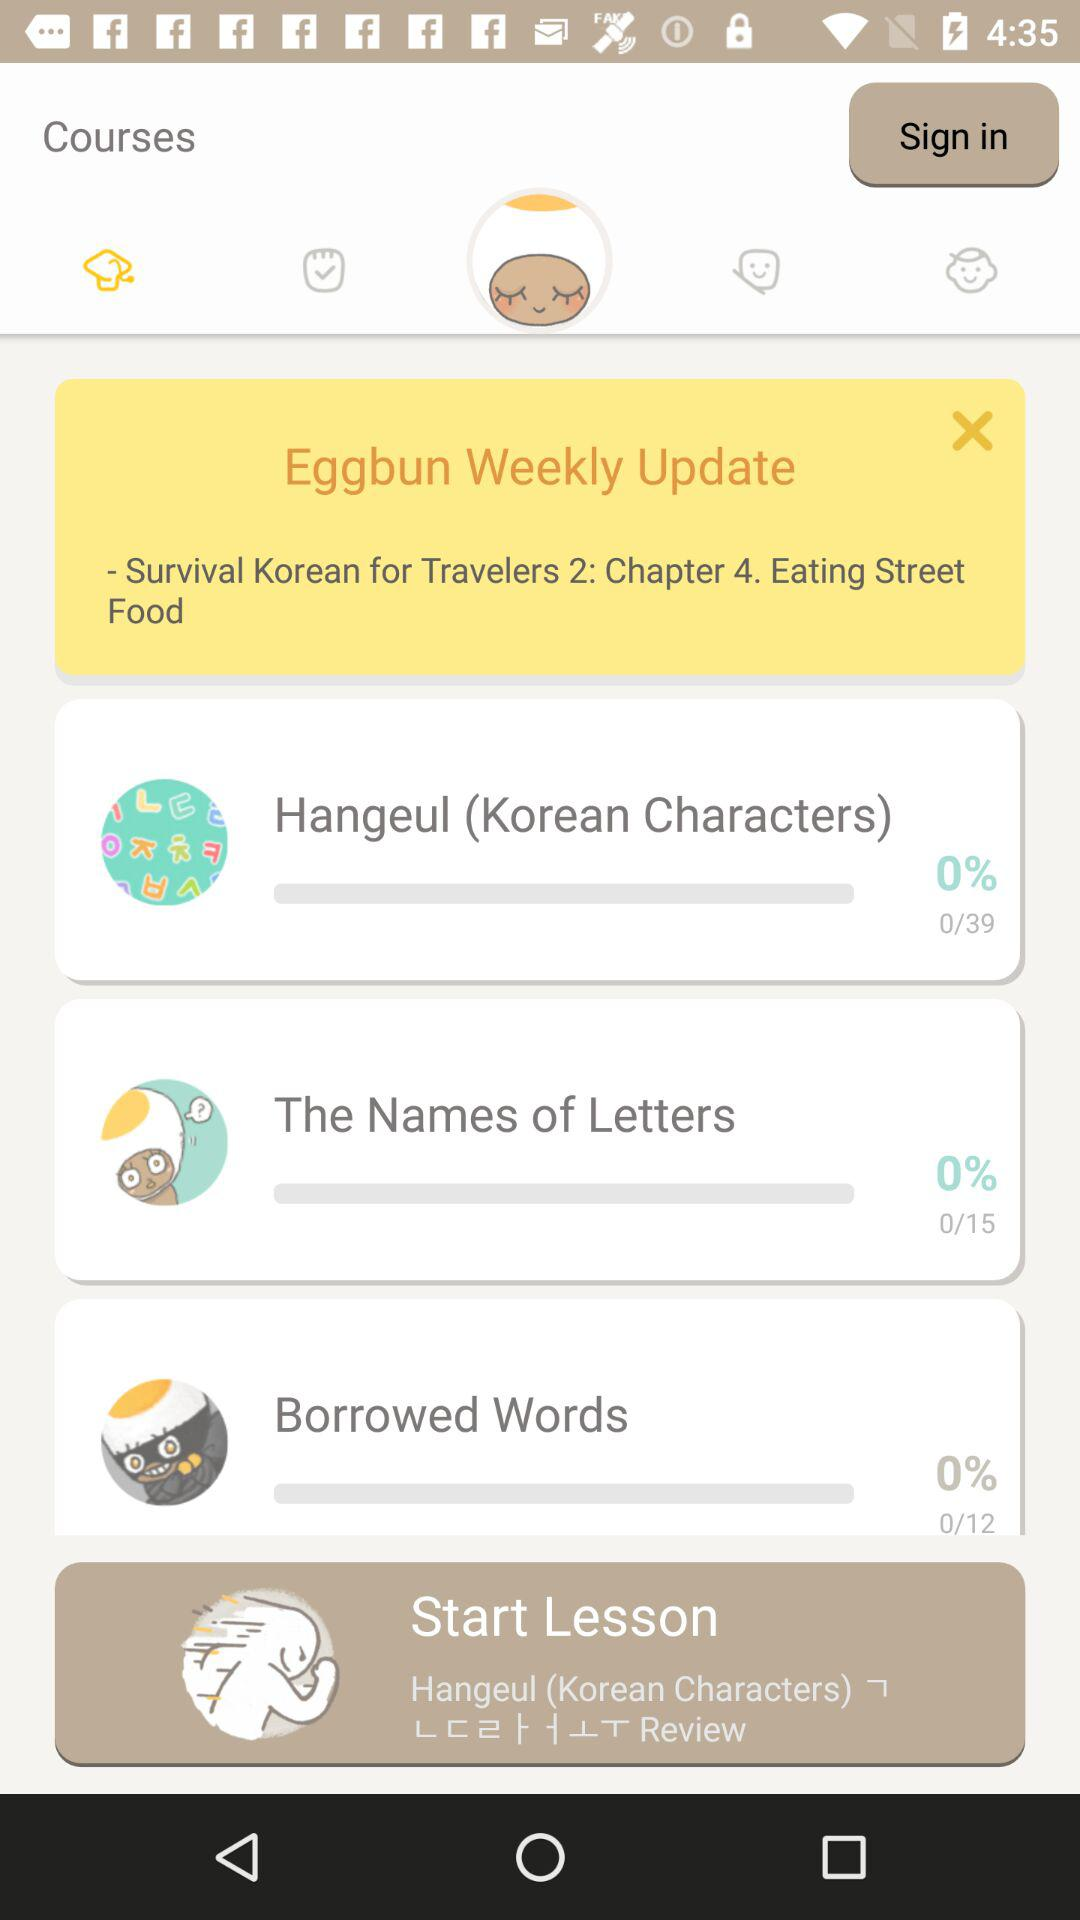How many lessons are there in the Survival Korean for Travelers 2 course?
Answer the question using a single word or phrase. 4 